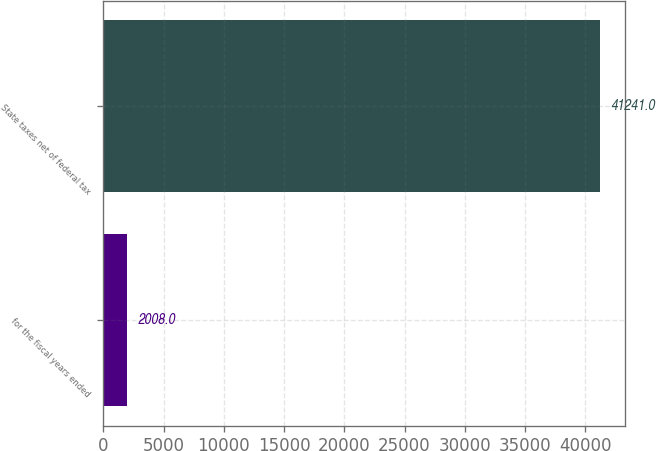<chart> <loc_0><loc_0><loc_500><loc_500><bar_chart><fcel>for the fiscal years ended<fcel>State taxes net of federal tax<nl><fcel>2008<fcel>41241<nl></chart> 